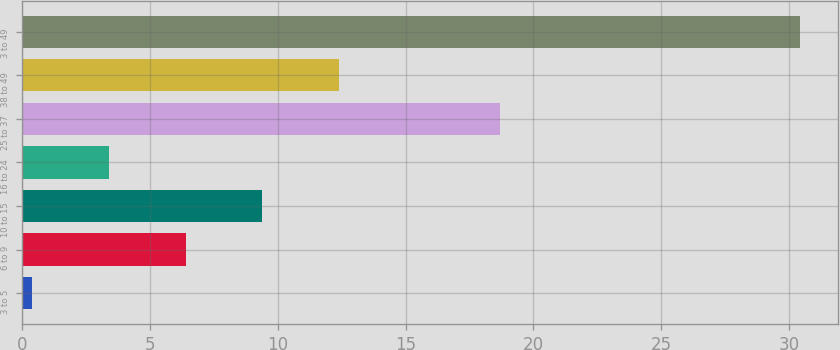<chart> <loc_0><loc_0><loc_500><loc_500><bar_chart><fcel>3 to 5<fcel>6 to 9<fcel>10 to 15<fcel>16 to 24<fcel>25 to 37<fcel>38 to 49<fcel>3 to 49<nl><fcel>0.4<fcel>6.4<fcel>9.4<fcel>3.4<fcel>18.7<fcel>12.4<fcel>30.4<nl></chart> 